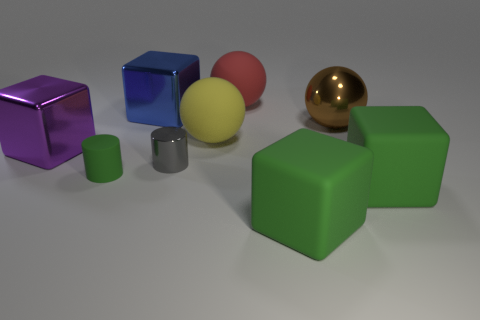What is the size of the other metal thing that is the same shape as the purple shiny object?
Provide a short and direct response. Large. Are there more large metallic things on the right side of the big blue block than big blue objects that are to the left of the purple metal block?
Provide a succinct answer. Yes. Does the large brown sphere have the same material as the sphere on the left side of the large red sphere?
Your answer should be compact. No. What is the color of the big thing that is in front of the large red rubber object and behind the big brown metallic object?
Your response must be concise. Blue. What is the shape of the green thing that is left of the big red sphere?
Ensure brevity in your answer.  Cylinder. How big is the metallic thing right of the small object that is right of the metal cube that is to the right of the purple object?
Keep it short and to the point. Large. What number of blocks are in front of the small thing behind the small green thing?
Provide a short and direct response. 2. What is the size of the thing that is both on the left side of the brown metallic thing and in front of the tiny green matte cylinder?
Provide a succinct answer. Large. What number of matte things are large blocks or small purple cubes?
Offer a very short reply. 2. What is the material of the small green thing?
Your answer should be compact. Rubber. 